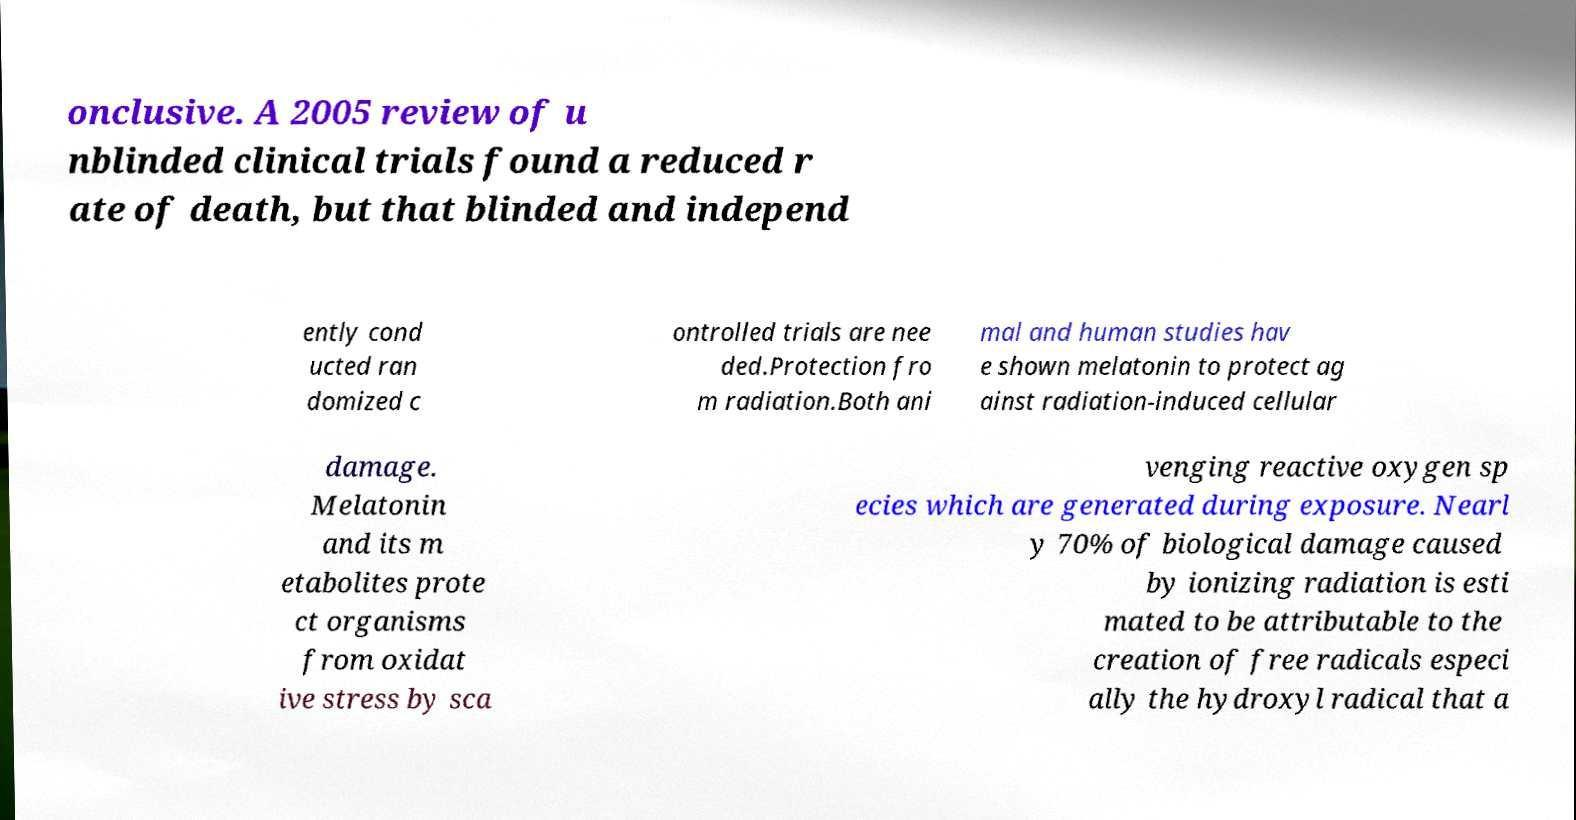Please identify and transcribe the text found in this image. onclusive. A 2005 review of u nblinded clinical trials found a reduced r ate of death, but that blinded and independ ently cond ucted ran domized c ontrolled trials are nee ded.Protection fro m radiation.Both ani mal and human studies hav e shown melatonin to protect ag ainst radiation-induced cellular damage. Melatonin and its m etabolites prote ct organisms from oxidat ive stress by sca venging reactive oxygen sp ecies which are generated during exposure. Nearl y 70% of biological damage caused by ionizing radiation is esti mated to be attributable to the creation of free radicals especi ally the hydroxyl radical that a 